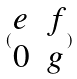<formula> <loc_0><loc_0><loc_500><loc_500>( \begin{matrix} e & f \\ 0 & g \end{matrix} )</formula> 